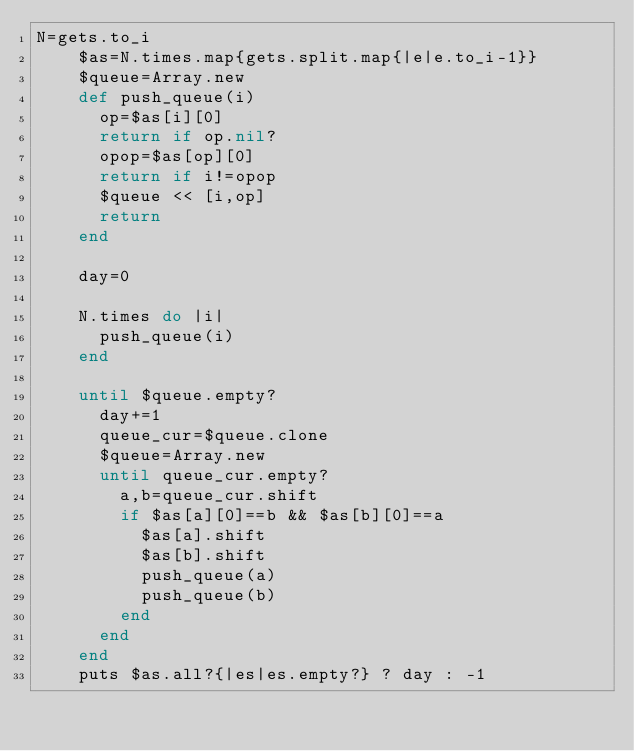Convert code to text. <code><loc_0><loc_0><loc_500><loc_500><_Ruby_>N=gets.to_i
    $as=N.times.map{gets.split.map{|e|e.to_i-1}}
    $queue=Array.new
    def push_queue(i)
      op=$as[i][0]
      return if op.nil?
      opop=$as[op][0]
      return if i!=opop
      $queue << [i,op]
      return
    end
     
    day=0
     
    N.times do |i|
      push_queue(i)
    end
     
    until $queue.empty?
      day+=1
      queue_cur=$queue.clone
      $queue=Array.new
      until queue_cur.empty?
        a,b=queue_cur.shift
        if $as[a][0]==b && $as[b][0]==a
          $as[a].shift
          $as[b].shift
          push_queue(a)
          push_queue(b)
        end
      end
    end
    puts $as.all?{|es|es.empty?} ? day : -1
</code> 